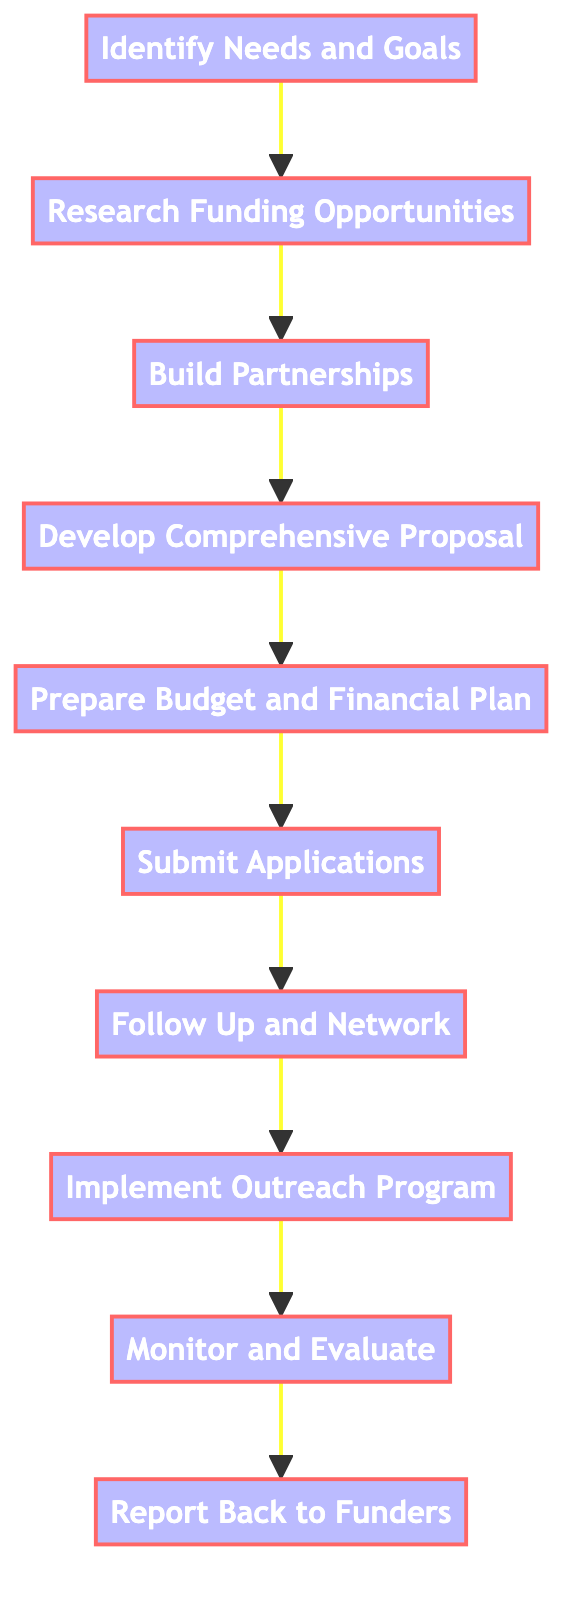What is the first step in the process? The first step is depicted at the start of the flowchart, labeled "Identify Needs and Goals." This is the initial node in the sequence of steps.
Answer: Identify Needs and Goals How many steps are there in total? By counting the number of nodes, we see there are ten distinct steps represented in the flowchart.
Answer: 10 What follows after "Follow Up and Network"? The step that directly follows "Follow Up and Network" in the flowchart is "Implement Outreach Program." This can be found as the succeeding node.
Answer: Implement Outreach Program Which step involves creating a budget? The step that requires creating a budget is "Prepare Budget and Financial Plan." This step is specifically focused on financial aspects as indicated in the flowchart.
Answer: Prepare Budget and Financial Plan What is the relationship between "Research Funding Opportunities" and "Build Partnerships"? The relationship is sequential; "Research Funding Opportunities" leads directly into "Build Partnerships," indicating that after researching, one should build partnerships. This is represented by a directed arrow between the two nodes.
Answer: Leads to What is the last step in the process? The last step is defined by the final node in the flowchart, which is "Report Back to Funders." This is the concluding action in securing funding for outreach programs.
Answer: Report Back to Funders How is "Develop a Comprehensive Proposal" related to "Submit Applications"? "Develop a Comprehensive Proposal" precedes "Submit Applications," indicating that one must first draft the proposal before submitting it, as shown by the flow of arrows between these two steps.
Answer: Precedes Which step emphasizes collaboration with external organizations? The step that emphasizes collaboration is "Build Partnerships," which focuses on strengthening connections with educational institutions and community organizations as part of the proposal process.
Answer: Build Partnerships What step communicates with potential funders? The step focused on communication with potential funders is "Follow Up and Network," which is aimed at maintaining relationships and networking to support funding applications.
Answer: Follow Up and Network 